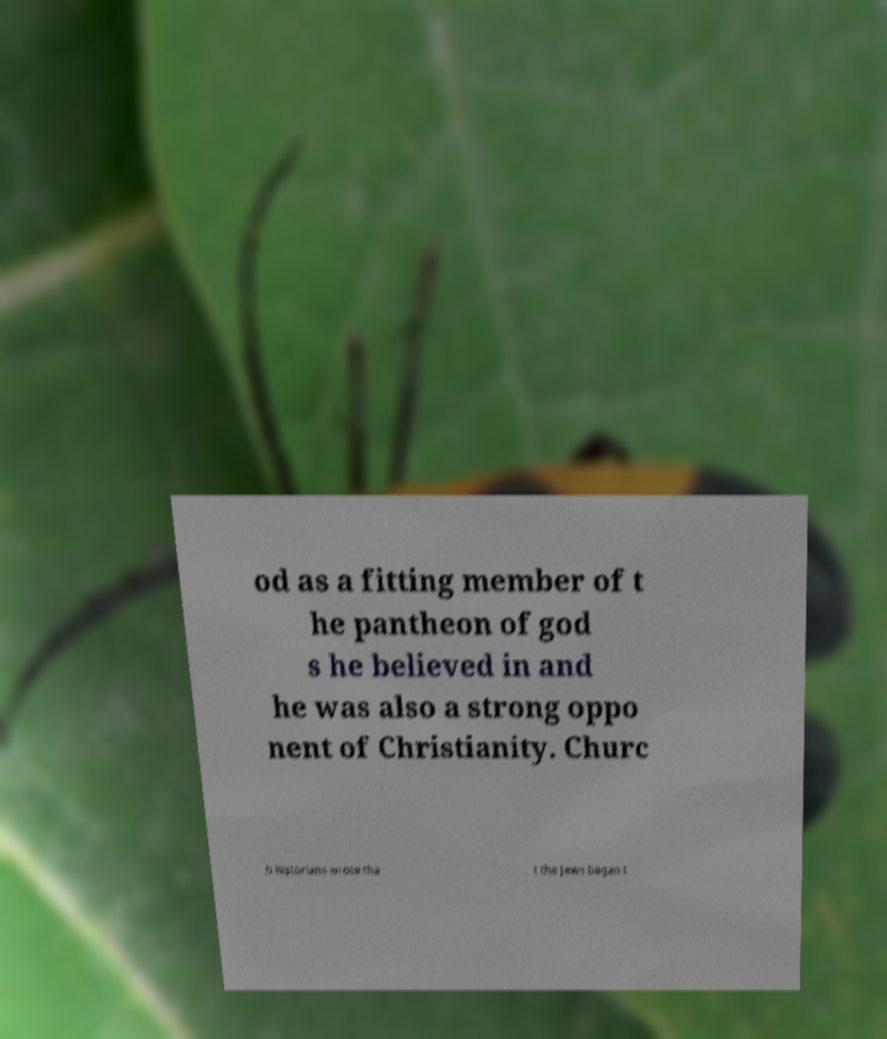I need the written content from this picture converted into text. Can you do that? od as a fitting member of t he pantheon of god s he believed in and he was also a strong oppo nent of Christianity. Churc h historians wrote tha t the Jews began t 